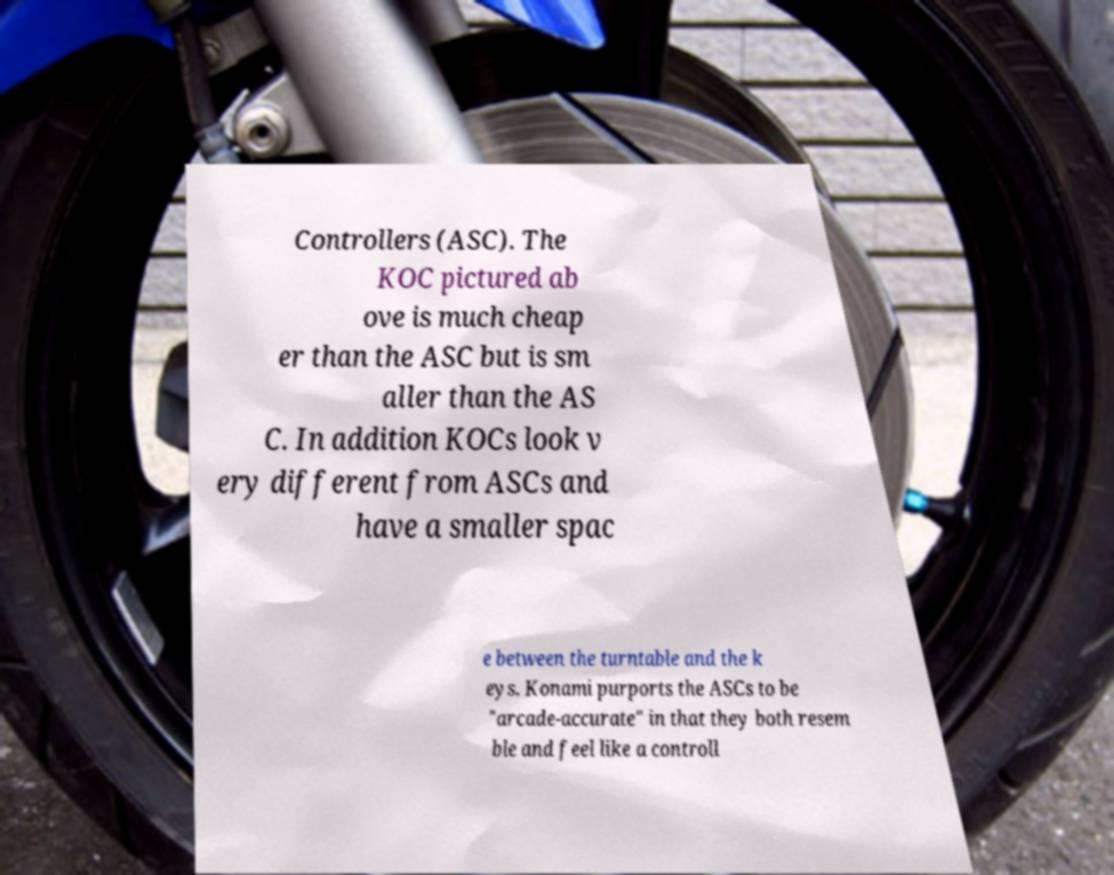Can you accurately transcribe the text from the provided image for me? Controllers (ASC). The KOC pictured ab ove is much cheap er than the ASC but is sm aller than the AS C. In addition KOCs look v ery different from ASCs and have a smaller spac e between the turntable and the k eys. Konami purports the ASCs to be "arcade-accurate" in that they both resem ble and feel like a controll 